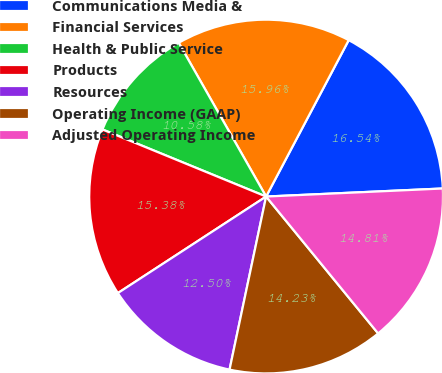Convert chart. <chart><loc_0><loc_0><loc_500><loc_500><pie_chart><fcel>Communications Media &<fcel>Financial Services<fcel>Health & Public Service<fcel>Products<fcel>Resources<fcel>Operating Income (GAAP)<fcel>Adjusted Operating Income<nl><fcel>16.54%<fcel>15.96%<fcel>10.58%<fcel>15.38%<fcel>12.5%<fcel>14.23%<fcel>14.81%<nl></chart> 